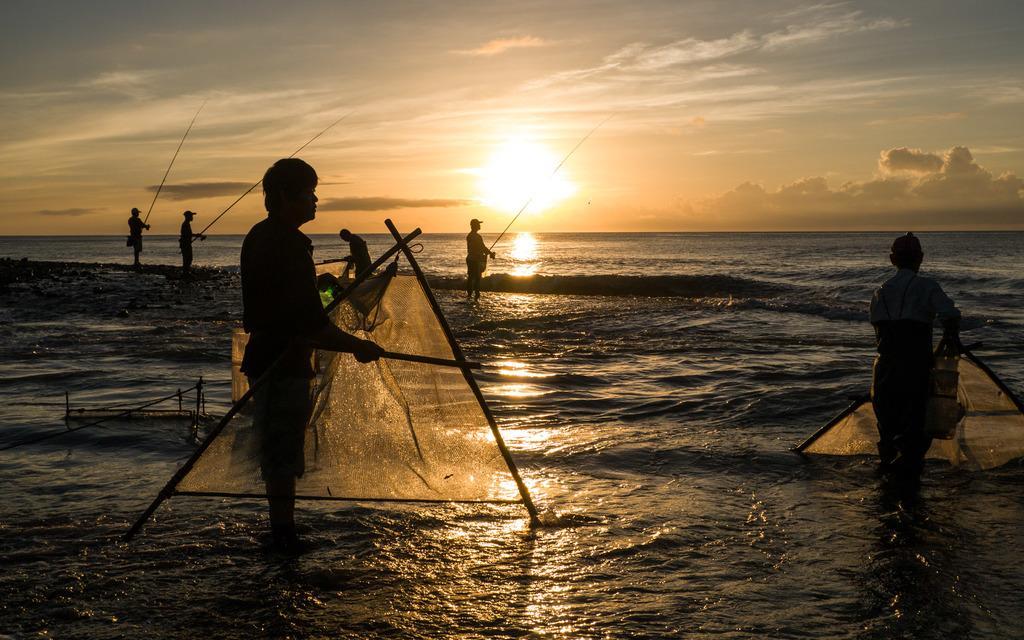Please provide a concise description of this image. In this image there are three persons standing in the water and holding the fishing nets, and at the background there are three persons standing in the water and holding the fishing rods , sky. 